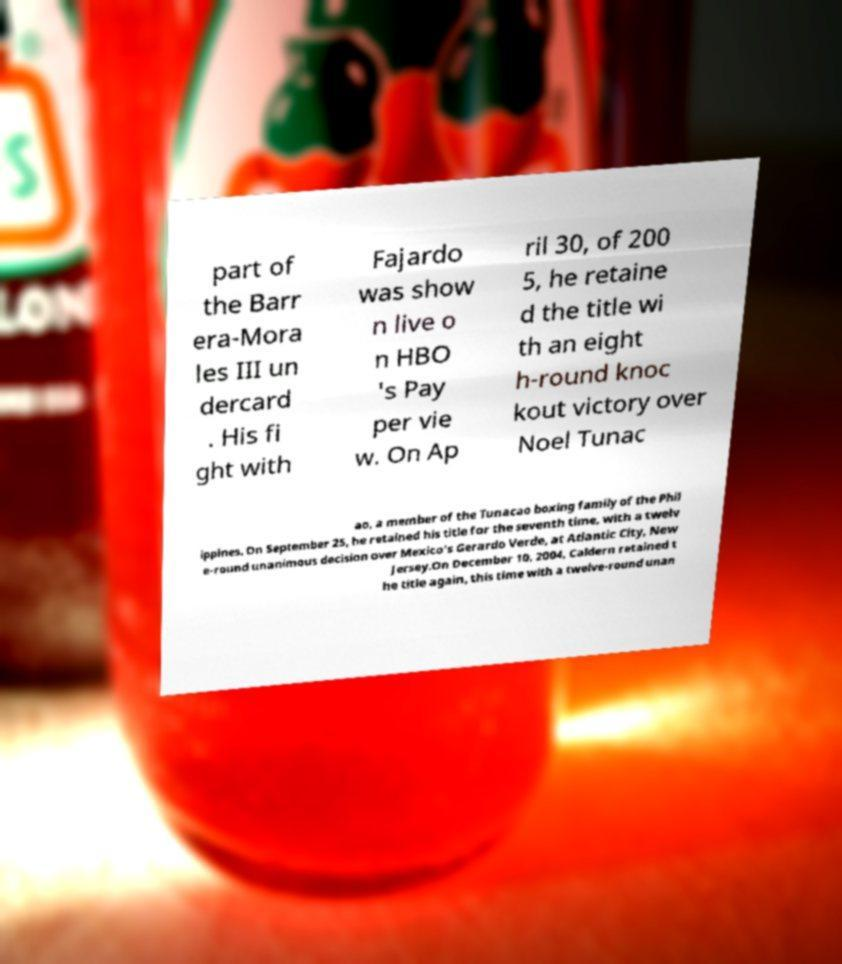I need the written content from this picture converted into text. Can you do that? part of the Barr era-Mora les III un dercard . His fi ght with Fajardo was show n live o n HBO 's Pay per vie w. On Ap ril 30, of 200 5, he retaine d the title wi th an eight h-round knoc kout victory over Noel Tunac ao, a member of the Tunacao boxing family of the Phil ippines. On September 25, he retained his title for the seventh time, with a twelv e-round unanimous decision over Mexico's Gerardo Verde, at Atlantic City, New Jersey.On December 10, 2004, Caldern retained t he title again, this time with a twelve-round unan 